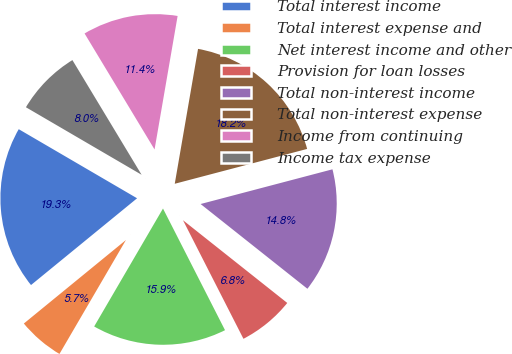Convert chart. <chart><loc_0><loc_0><loc_500><loc_500><pie_chart><fcel>Total interest income<fcel>Total interest expense and<fcel>Net interest income and other<fcel>Provision for loan losses<fcel>Total non-interest income<fcel>Total non-interest expense<fcel>Income from continuing<fcel>Income tax expense<nl><fcel>19.32%<fcel>5.68%<fcel>15.91%<fcel>6.82%<fcel>14.77%<fcel>18.18%<fcel>11.36%<fcel>7.95%<nl></chart> 